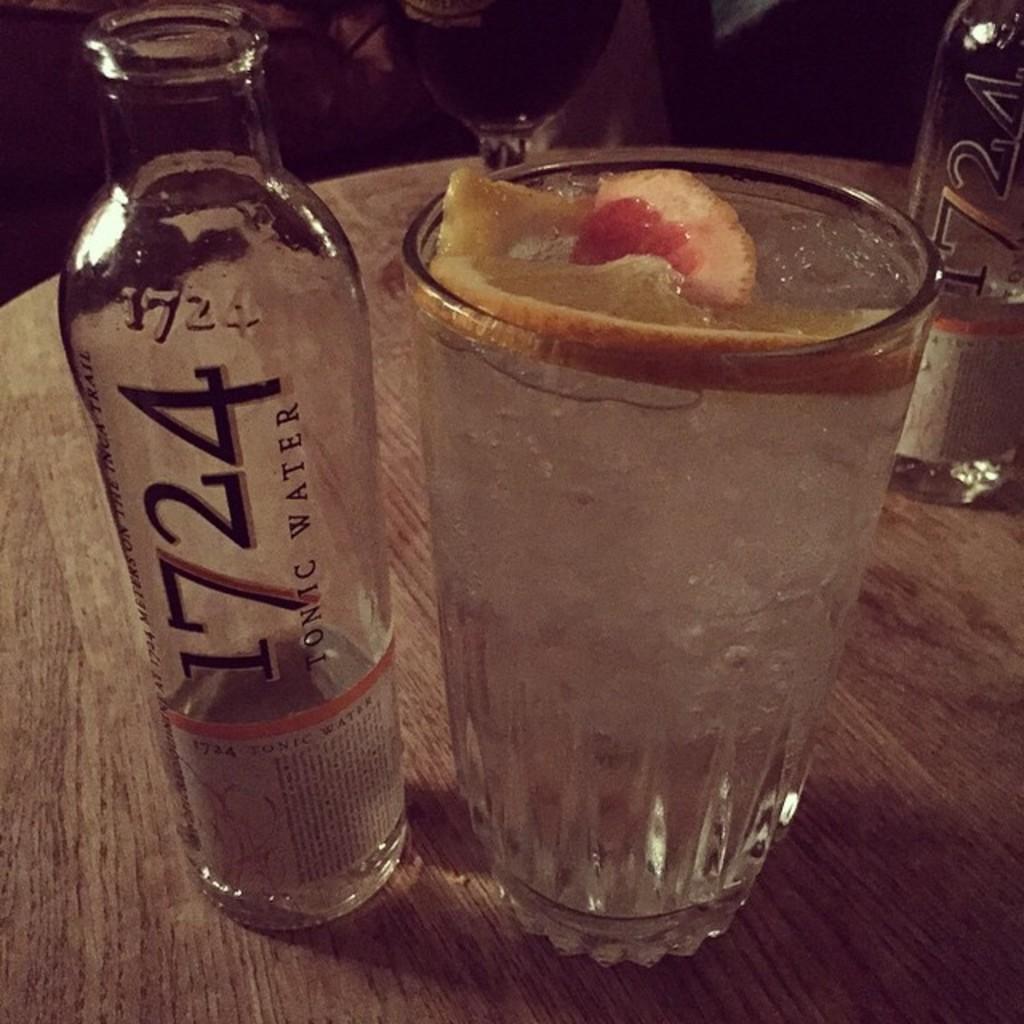What type of drink is sitting next to the glass?
Your answer should be very brief. Tonic water. What type of drink is in the glass?
Keep it short and to the point. Tonic water. 